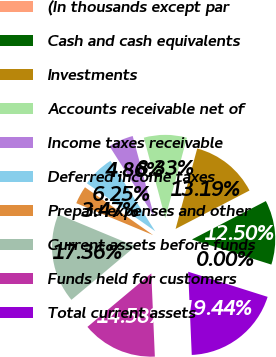<chart> <loc_0><loc_0><loc_500><loc_500><pie_chart><fcel>(In thousands except par<fcel>Cash and cash equivalents<fcel>Investments<fcel>Accounts receivable net of<fcel>Income taxes receivable<fcel>Deferred income taxes<fcel>Prepaid expenses and other<fcel>Current assets before funds<fcel>Funds held for customers<fcel>Total current assets<nl><fcel>0.0%<fcel>12.5%<fcel>13.19%<fcel>8.33%<fcel>4.86%<fcel>6.25%<fcel>3.47%<fcel>17.36%<fcel>14.58%<fcel>19.44%<nl></chart> 